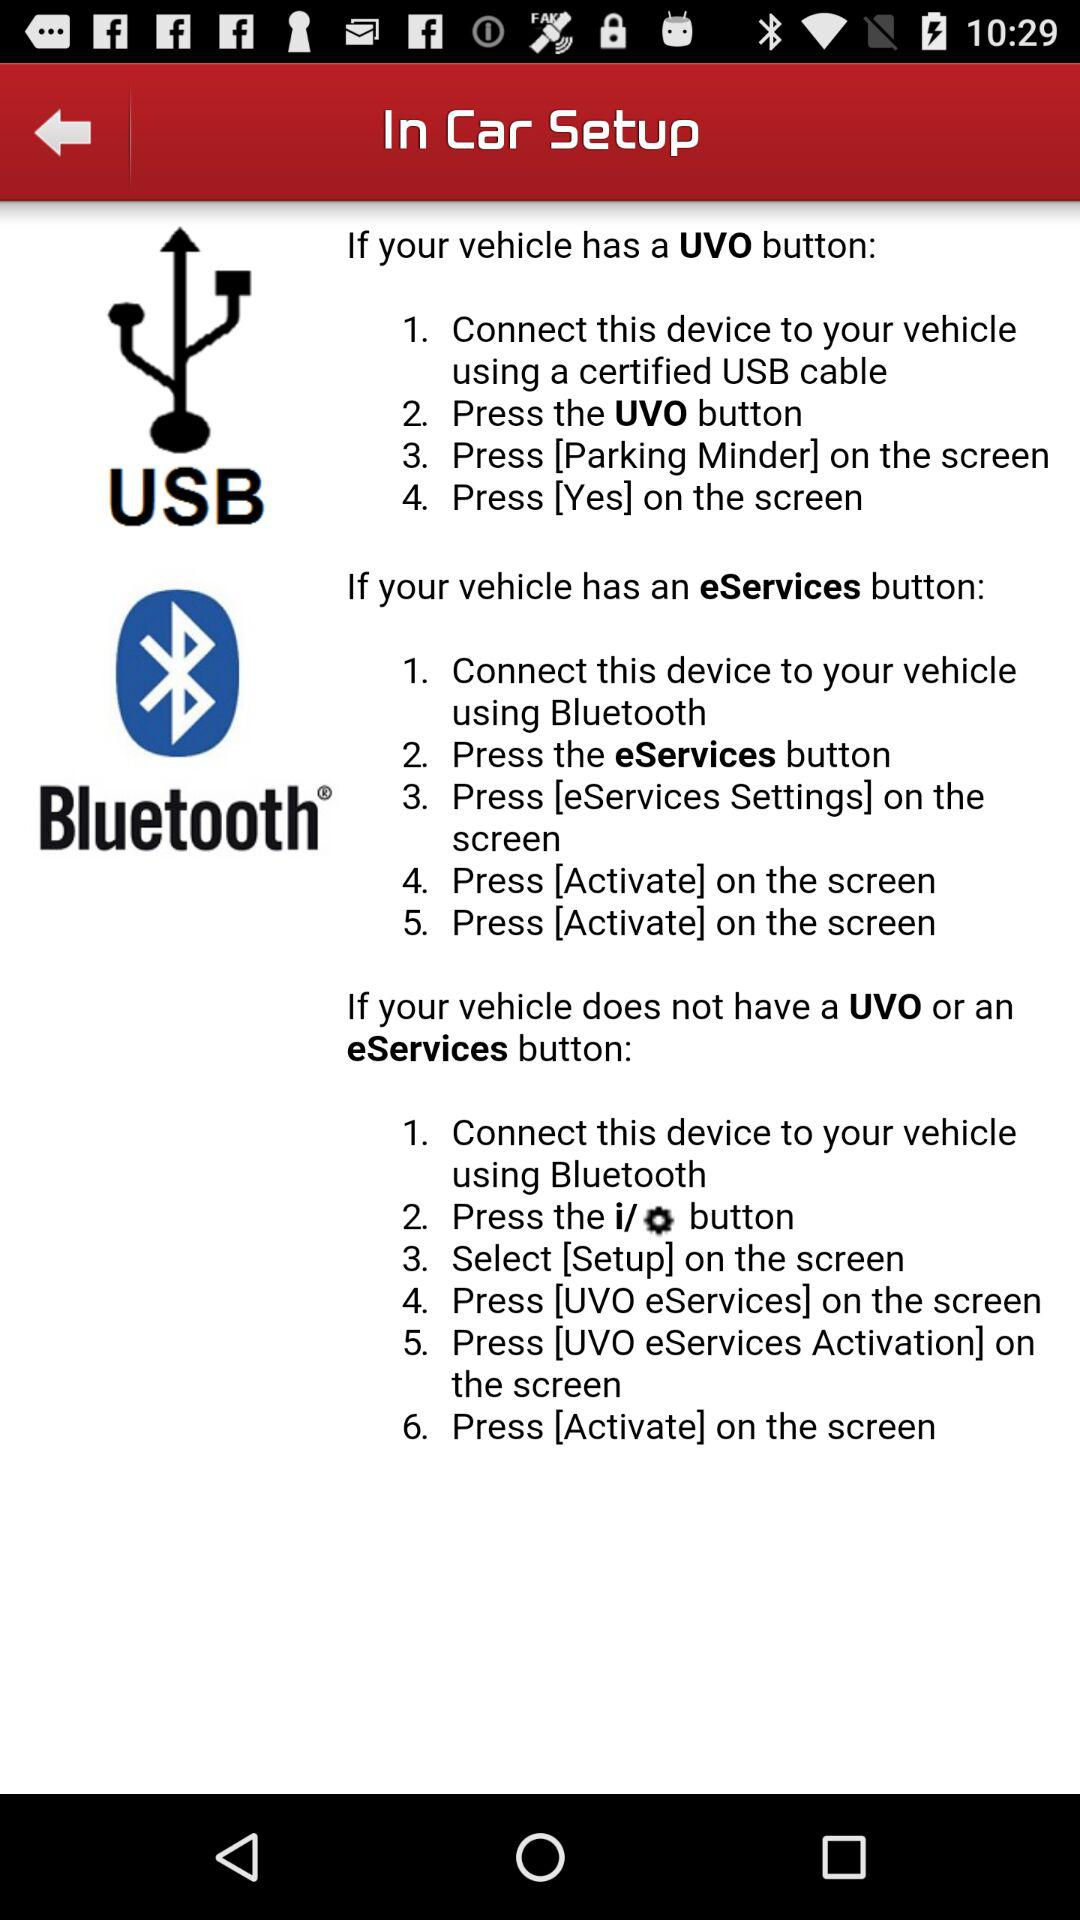Which cable is required to set up a connection between the car and the device? The required cable is the certified USB cable. 